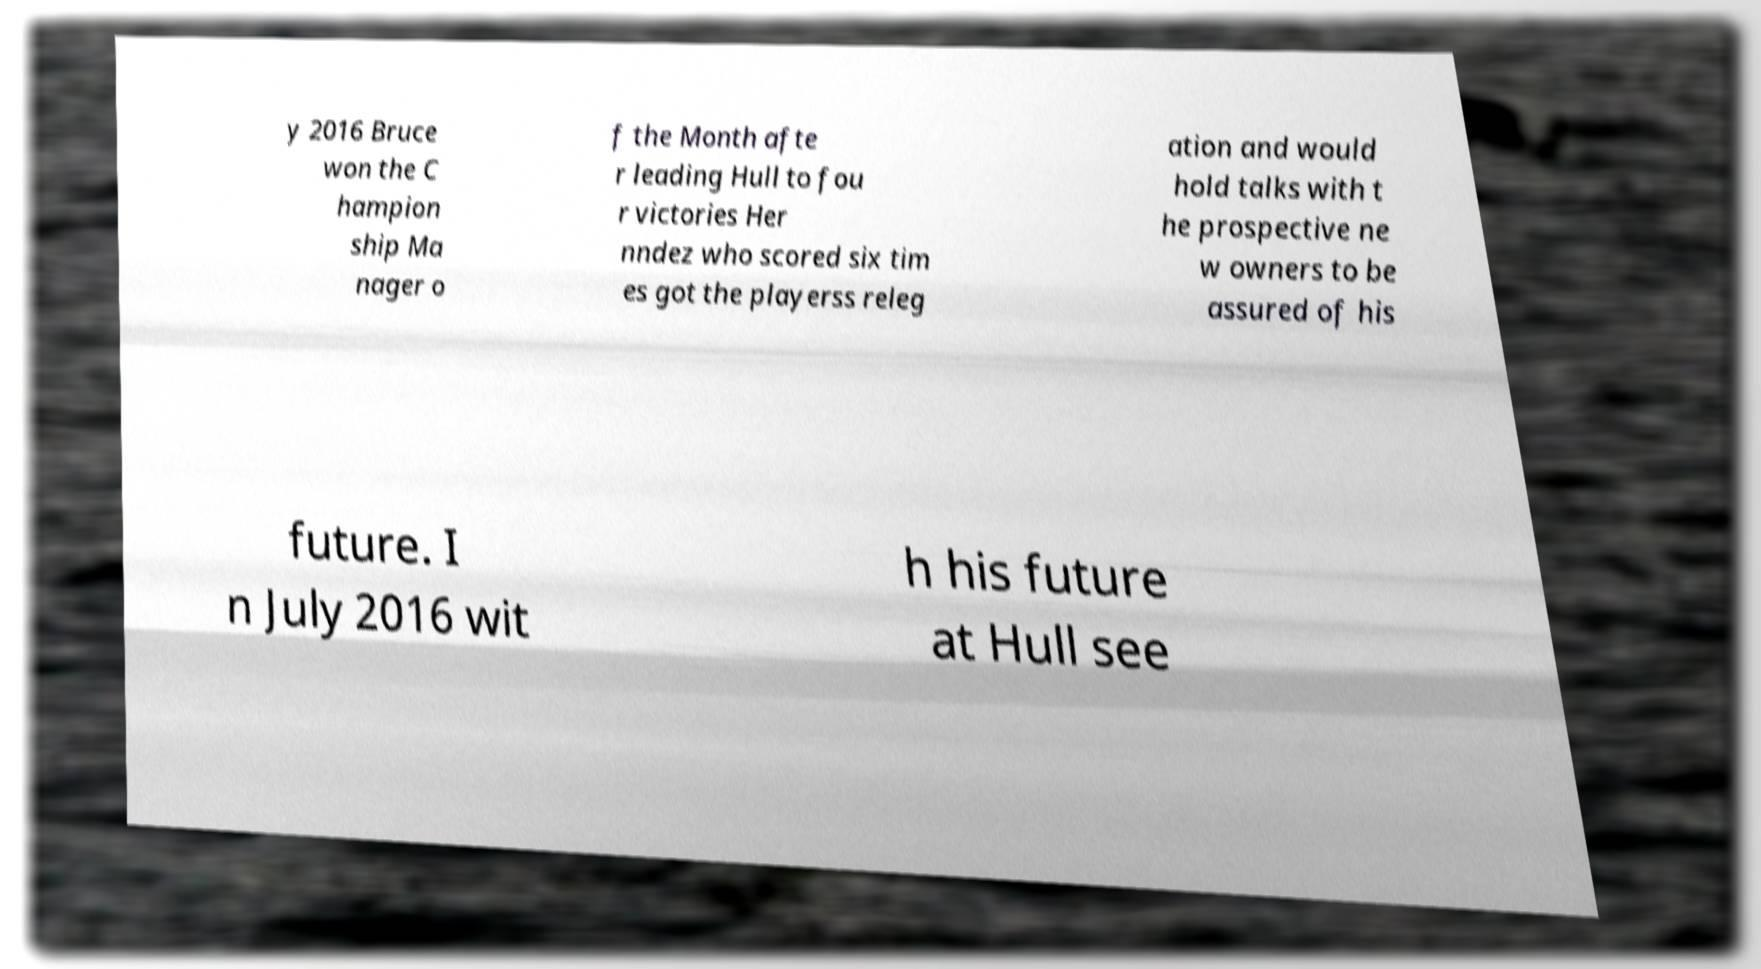What messages or text are displayed in this image? I need them in a readable, typed format. y 2016 Bruce won the C hampion ship Ma nager o f the Month afte r leading Hull to fou r victories Her nndez who scored six tim es got the playerss releg ation and would hold talks with t he prospective ne w owners to be assured of his future. I n July 2016 wit h his future at Hull see 